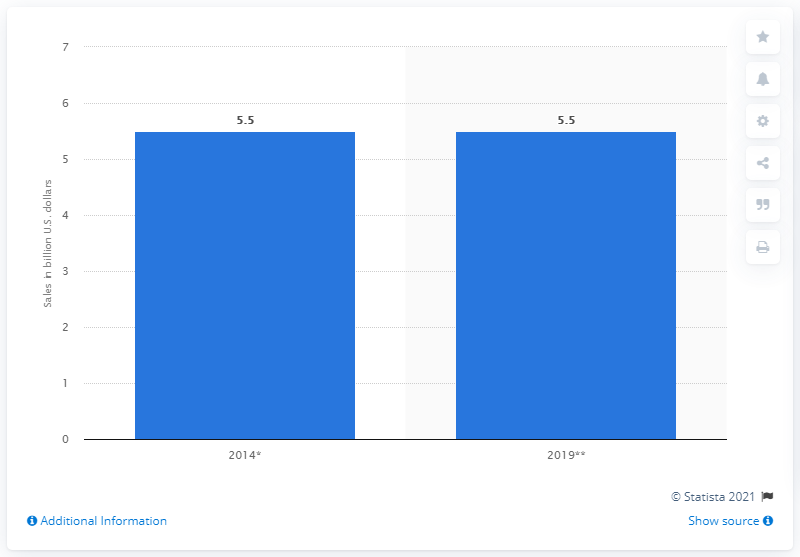Outline some significant characteristics in this image. In 2014, the estimated retail sales of pizza in the United States were approximately 5.5 billion dollars. According to a forecast, it is expected that pizza category sales will remain at 5.5 in 2019. 